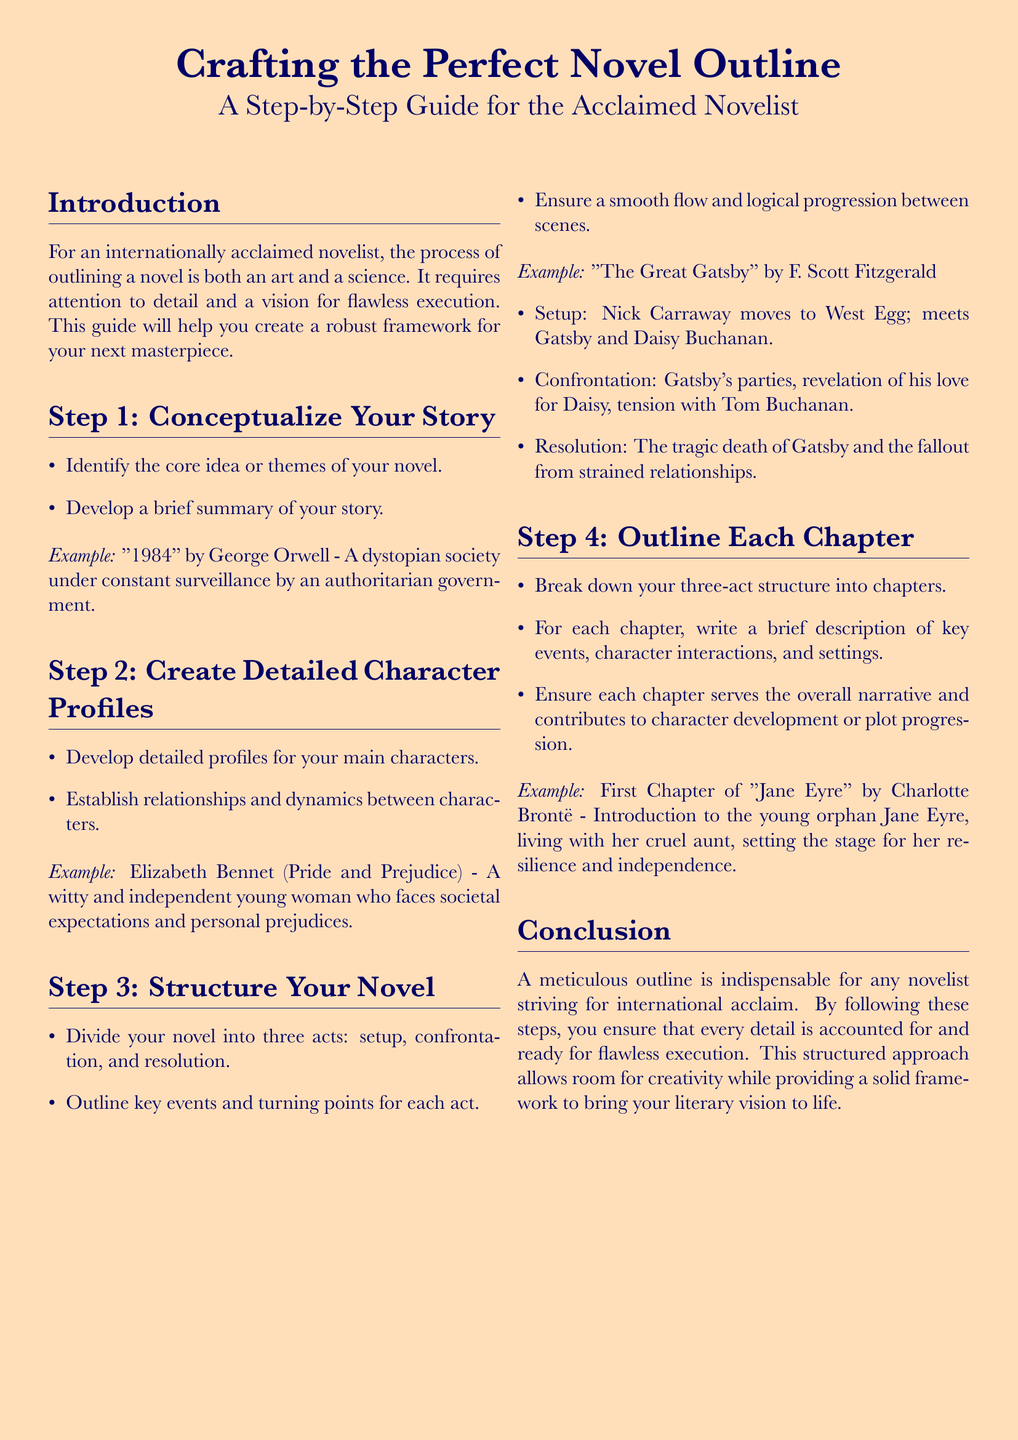What is the title of the document? The title is presented in a larger font and summarizes the content of the document, which is "Crafting the Perfect Novel Outline".
Answer: Crafting the Perfect Novel Outline Who is the intended audience for this guide? The intended audience is specified in the introduction as "an internationally acclaimed novelist".
Answer: internationally acclaimed novelist What are the three acts mentioned in the structure? The document outlines the structure of a novel into three acts: setup, confrontation, and resolution.
Answer: setup, confrontation, resolution What is the first step in creating a novel outline? The first step is detailed in the document as "Conceptualize Your Story".
Answer: Conceptualize Your Story Which character is used as an example in Step 2? The example character provided for the second step is Elizabeth Bennet from "Pride and Prejudice".
Answer: Elizabeth Bennet What should each chapter contribute to the overall narrative? The document states that each chapter should serve the overall narrative and contribute to character development or plot progression.
Answer: character development or plot progression In which chapter is the introduction to Jane Eyre mentioned? The introduction to Jane Eyre is mentioned in the first chapter of the example provided.
Answer: First Chapter What is emphasized as indispensable for achieving international acclaim? The conclusion emphasizes that a meticulous outline is indispensable for any novelist striving for international acclaim.
Answer: meticulous outline 